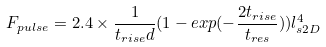Convert formula to latex. <formula><loc_0><loc_0><loc_500><loc_500>F _ { p u l s e } = 2 . 4 \times \frac { 1 } { t _ { r i s e } d } ( 1 - e x p ( - \frac { 2 t _ { r i s e } } { t _ { r e s } } ) ) l _ { s 2 D } ^ { 4 }</formula> 